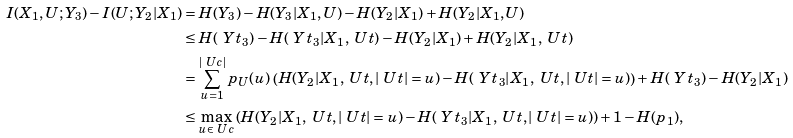Convert formula to latex. <formula><loc_0><loc_0><loc_500><loc_500>I ( X _ { 1 } , U ; Y _ { 3 } ) - I ( U ; Y _ { 2 } | X _ { 1 } ) & = H ( Y _ { 3 } ) - H ( Y _ { 3 } | X _ { 1 } , U ) - H ( Y _ { 2 } | X _ { 1 } ) + H ( Y _ { 2 } | X _ { 1 } , U ) \\ & \leq H ( \ Y t _ { 3 } ) - H ( \ Y t _ { 3 } | X _ { 1 } , \ U t ) - H ( Y _ { 2 } | X _ { 1 } ) + H ( Y _ { 2 } | X _ { 1 } , \ U t ) \\ & = \sum _ { u = 1 } ^ { | \ U c | } p _ { U } ( u ) \, \left ( H ( Y _ { 2 } | X _ { 1 } , \ U t , | \ U t | = u ) - H ( \ Y t _ { 3 } | X _ { 1 } , \ U t , | \ U t | = u ) \right ) + H ( \ Y t _ { 3 } ) - H ( Y _ { 2 } | X _ { 1 } ) \\ & \leq \max _ { u \in \ U c } \left ( H ( Y _ { 2 } | X _ { 1 } , \ U t , | \ U t | = u ) - H ( \ Y t _ { 3 } | X _ { 1 } , \ U t , | \ U t | = u ) \right ) + 1 - H ( p _ { 1 } ) ,</formula> 